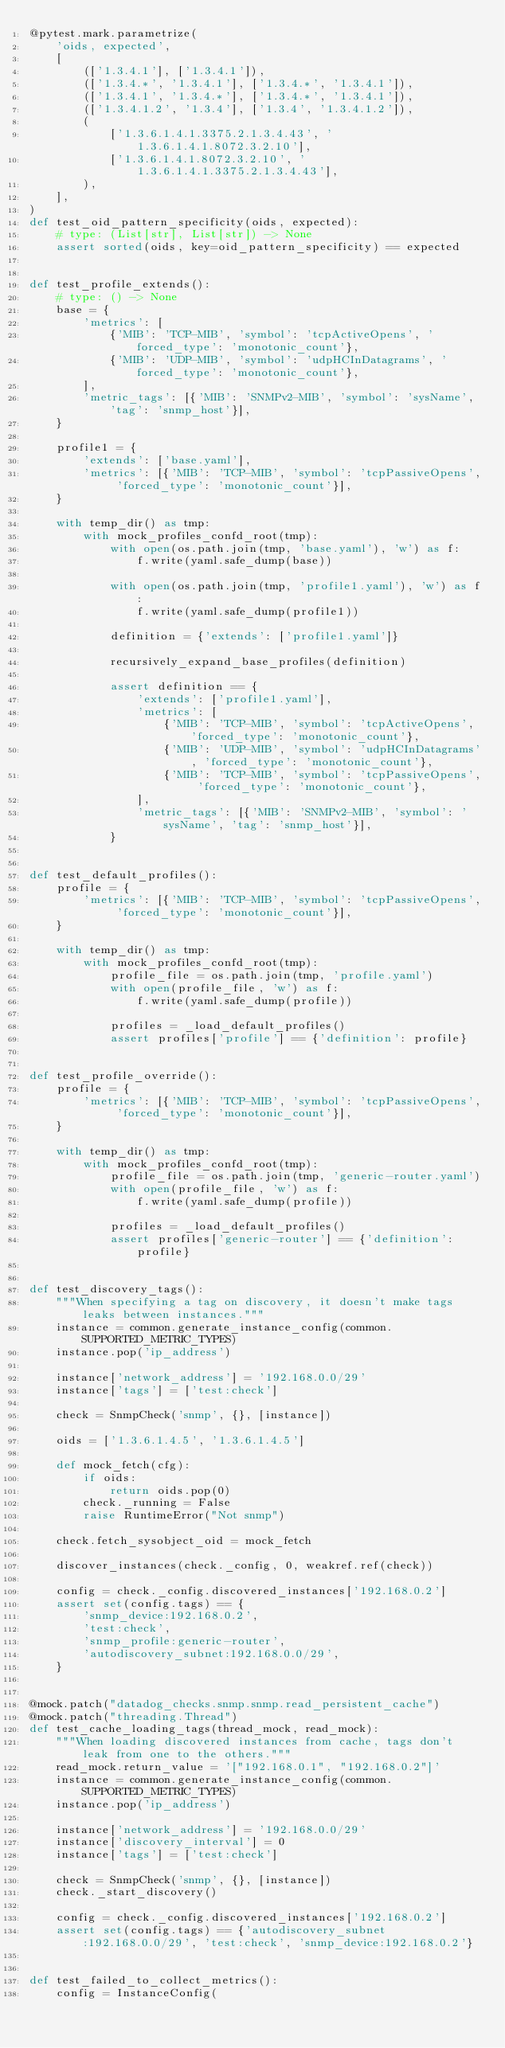<code> <loc_0><loc_0><loc_500><loc_500><_Python_>@pytest.mark.parametrize(
    'oids, expected',
    [
        (['1.3.4.1'], ['1.3.4.1']),
        (['1.3.4.*', '1.3.4.1'], ['1.3.4.*', '1.3.4.1']),
        (['1.3.4.1', '1.3.4.*'], ['1.3.4.*', '1.3.4.1']),
        (['1.3.4.1.2', '1.3.4'], ['1.3.4', '1.3.4.1.2']),
        (
            ['1.3.6.1.4.1.3375.2.1.3.4.43', '1.3.6.1.4.1.8072.3.2.10'],
            ['1.3.6.1.4.1.8072.3.2.10', '1.3.6.1.4.1.3375.2.1.3.4.43'],
        ),
    ],
)
def test_oid_pattern_specificity(oids, expected):
    # type: (List[str], List[str]) -> None
    assert sorted(oids, key=oid_pattern_specificity) == expected


def test_profile_extends():
    # type: () -> None
    base = {
        'metrics': [
            {'MIB': 'TCP-MIB', 'symbol': 'tcpActiveOpens', 'forced_type': 'monotonic_count'},
            {'MIB': 'UDP-MIB', 'symbol': 'udpHCInDatagrams', 'forced_type': 'monotonic_count'},
        ],
        'metric_tags': [{'MIB': 'SNMPv2-MIB', 'symbol': 'sysName', 'tag': 'snmp_host'}],
    }

    profile1 = {
        'extends': ['base.yaml'],
        'metrics': [{'MIB': 'TCP-MIB', 'symbol': 'tcpPassiveOpens', 'forced_type': 'monotonic_count'}],
    }

    with temp_dir() as tmp:
        with mock_profiles_confd_root(tmp):
            with open(os.path.join(tmp, 'base.yaml'), 'w') as f:
                f.write(yaml.safe_dump(base))

            with open(os.path.join(tmp, 'profile1.yaml'), 'w') as f:
                f.write(yaml.safe_dump(profile1))

            definition = {'extends': ['profile1.yaml']}

            recursively_expand_base_profiles(definition)

            assert definition == {
                'extends': ['profile1.yaml'],
                'metrics': [
                    {'MIB': 'TCP-MIB', 'symbol': 'tcpActiveOpens', 'forced_type': 'monotonic_count'},
                    {'MIB': 'UDP-MIB', 'symbol': 'udpHCInDatagrams', 'forced_type': 'monotonic_count'},
                    {'MIB': 'TCP-MIB', 'symbol': 'tcpPassiveOpens', 'forced_type': 'monotonic_count'},
                ],
                'metric_tags': [{'MIB': 'SNMPv2-MIB', 'symbol': 'sysName', 'tag': 'snmp_host'}],
            }


def test_default_profiles():
    profile = {
        'metrics': [{'MIB': 'TCP-MIB', 'symbol': 'tcpPassiveOpens', 'forced_type': 'monotonic_count'}],
    }

    with temp_dir() as tmp:
        with mock_profiles_confd_root(tmp):
            profile_file = os.path.join(tmp, 'profile.yaml')
            with open(profile_file, 'w') as f:
                f.write(yaml.safe_dump(profile))

            profiles = _load_default_profiles()
            assert profiles['profile'] == {'definition': profile}


def test_profile_override():
    profile = {
        'metrics': [{'MIB': 'TCP-MIB', 'symbol': 'tcpPassiveOpens', 'forced_type': 'monotonic_count'}],
    }

    with temp_dir() as tmp:
        with mock_profiles_confd_root(tmp):
            profile_file = os.path.join(tmp, 'generic-router.yaml')
            with open(profile_file, 'w') as f:
                f.write(yaml.safe_dump(profile))

            profiles = _load_default_profiles()
            assert profiles['generic-router'] == {'definition': profile}


def test_discovery_tags():
    """When specifying a tag on discovery, it doesn't make tags leaks between instances."""
    instance = common.generate_instance_config(common.SUPPORTED_METRIC_TYPES)
    instance.pop('ip_address')

    instance['network_address'] = '192.168.0.0/29'
    instance['tags'] = ['test:check']

    check = SnmpCheck('snmp', {}, [instance])

    oids = ['1.3.6.1.4.5', '1.3.6.1.4.5']

    def mock_fetch(cfg):
        if oids:
            return oids.pop(0)
        check._running = False
        raise RuntimeError("Not snmp")

    check.fetch_sysobject_oid = mock_fetch

    discover_instances(check._config, 0, weakref.ref(check))

    config = check._config.discovered_instances['192.168.0.2']
    assert set(config.tags) == {
        'snmp_device:192.168.0.2',
        'test:check',
        'snmp_profile:generic-router',
        'autodiscovery_subnet:192.168.0.0/29',
    }


@mock.patch("datadog_checks.snmp.snmp.read_persistent_cache")
@mock.patch("threading.Thread")
def test_cache_loading_tags(thread_mock, read_mock):
    """When loading discovered instances from cache, tags don't leak from one to the others."""
    read_mock.return_value = '["192.168.0.1", "192.168.0.2"]'
    instance = common.generate_instance_config(common.SUPPORTED_METRIC_TYPES)
    instance.pop('ip_address')

    instance['network_address'] = '192.168.0.0/29'
    instance['discovery_interval'] = 0
    instance['tags'] = ['test:check']

    check = SnmpCheck('snmp', {}, [instance])
    check._start_discovery()

    config = check._config.discovered_instances['192.168.0.2']
    assert set(config.tags) == {'autodiscovery_subnet:192.168.0.0/29', 'test:check', 'snmp_device:192.168.0.2'}


def test_failed_to_collect_metrics():
    config = InstanceConfig(</code> 